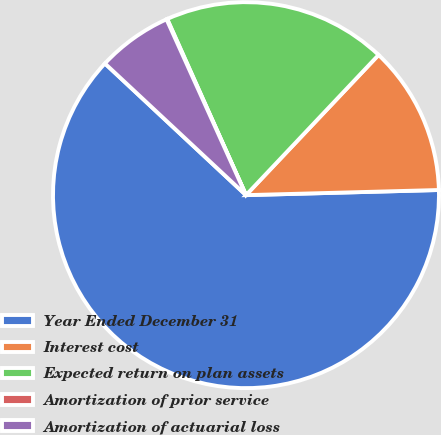<chart> <loc_0><loc_0><loc_500><loc_500><pie_chart><fcel>Year Ended December 31<fcel>Interest cost<fcel>Expected return on plan assets<fcel>Amortization of prior service<fcel>Amortization of actuarial loss<nl><fcel>62.37%<fcel>12.52%<fcel>18.75%<fcel>0.06%<fcel>6.29%<nl></chart> 